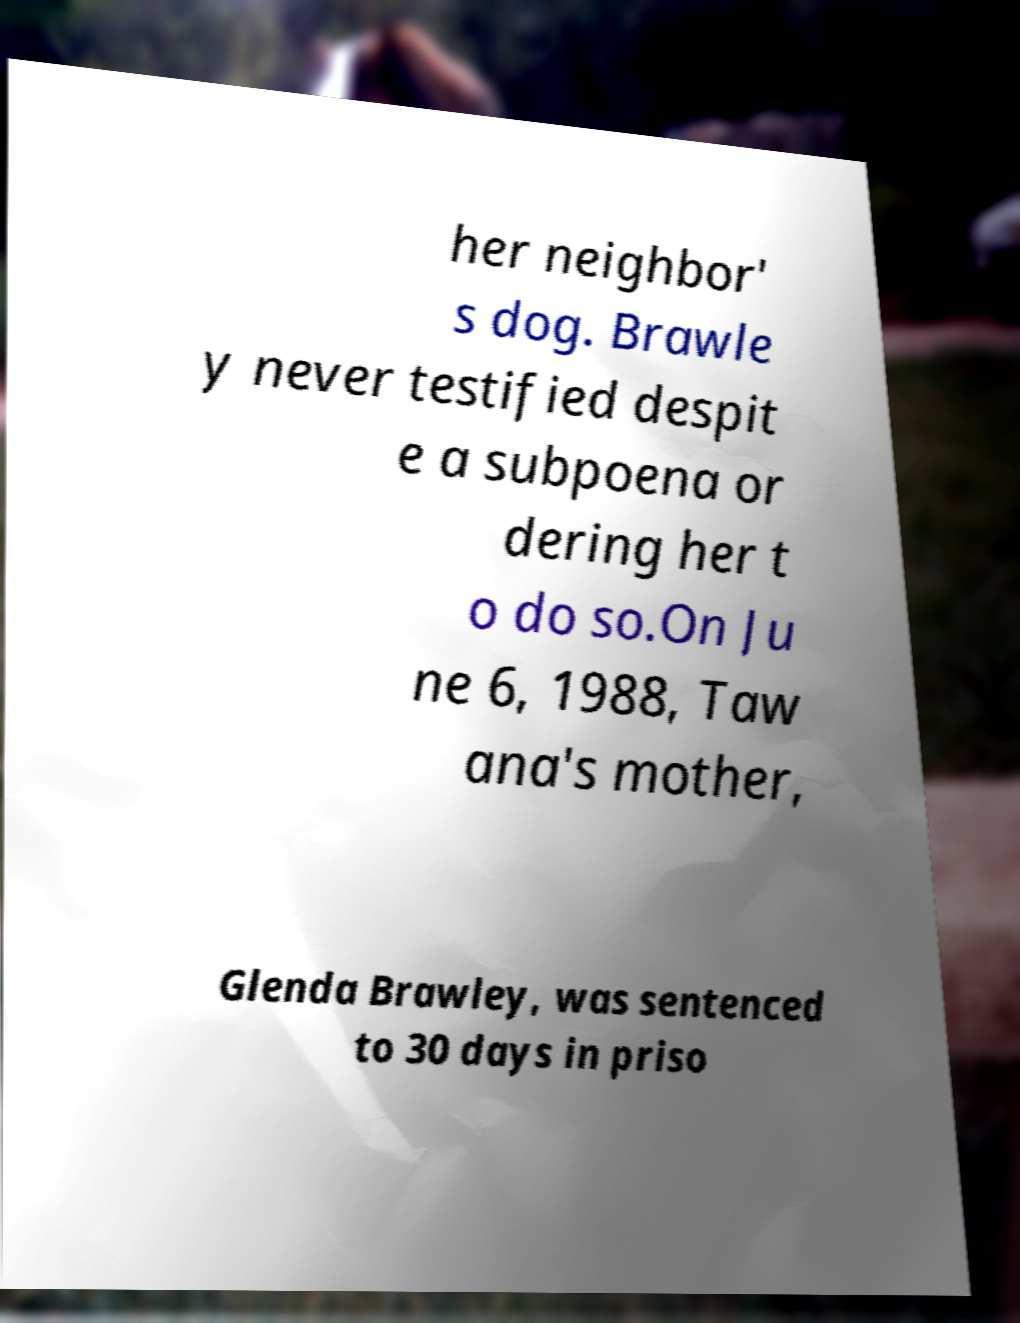Please read and relay the text visible in this image. What does it say? her neighbor' s dog. Brawle y never testified despit e a subpoena or dering her t o do so.On Ju ne 6, 1988, Taw ana's mother, Glenda Brawley, was sentenced to 30 days in priso 